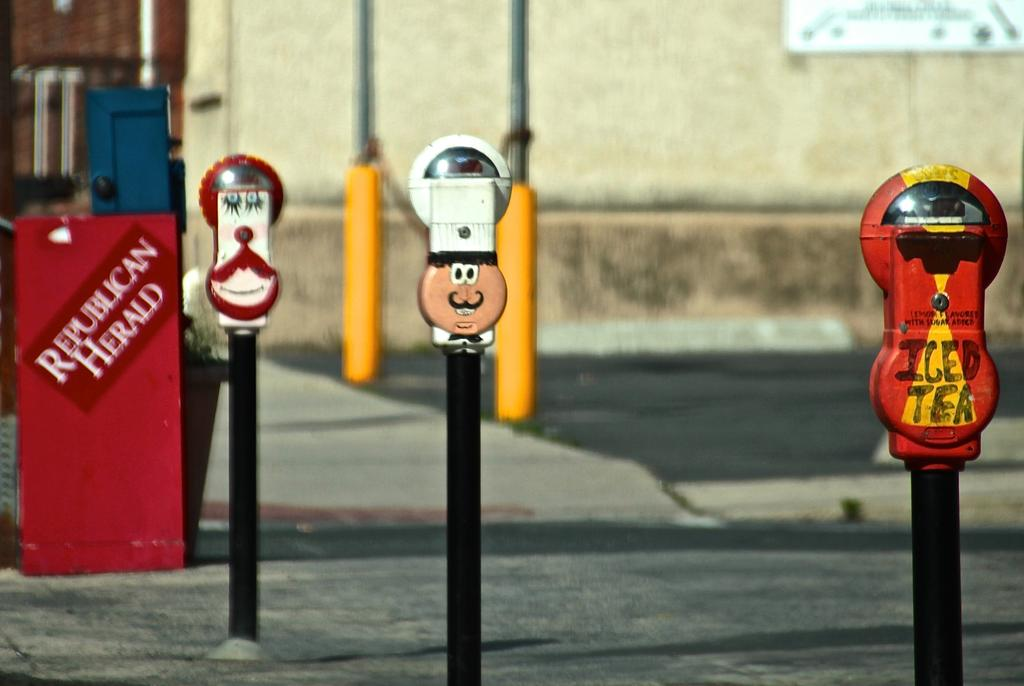<image>
Present a compact description of the photo's key features. several parking meters, one which says iced tea 